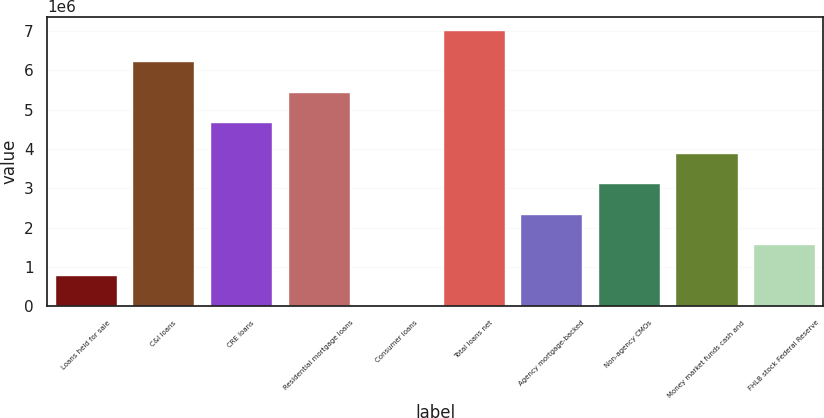Convert chart to OTSL. <chart><loc_0><loc_0><loc_500><loc_500><bar_chart><fcel>Loans held for sale<fcel>C&I loans<fcel>CRE loans<fcel>Residential mortgage loans<fcel>Consumer loans<fcel>Total loans net<fcel>Agency mortgage-backed<fcel>Non-agency CMOs<fcel>Money market funds cash and<fcel>FHLB stock Federal Reserve<nl><fcel>798677<fcel>6.23597e+06<fcel>4.68246e+06<fcel>5.45921e+06<fcel>21921<fcel>7.01272e+06<fcel>2.35219e+06<fcel>3.12894e+06<fcel>3.9057e+06<fcel>1.57543e+06<nl></chart> 